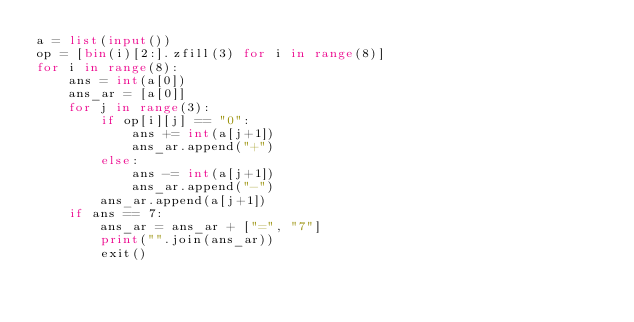<code> <loc_0><loc_0><loc_500><loc_500><_Python_>a = list(input())
op = [bin(i)[2:].zfill(3) for i in range(8)]
for i in range(8):
    ans = int(a[0])
    ans_ar = [a[0]]
    for j in range(3):
        if op[i][j] == "0":
            ans += int(a[j+1])
            ans_ar.append("+")
        else:
            ans -= int(a[j+1])
            ans_ar.append("-")
        ans_ar.append(a[j+1])
    if ans == 7:
        ans_ar = ans_ar + ["=", "7"]
        print("".join(ans_ar))
        exit()


</code> 